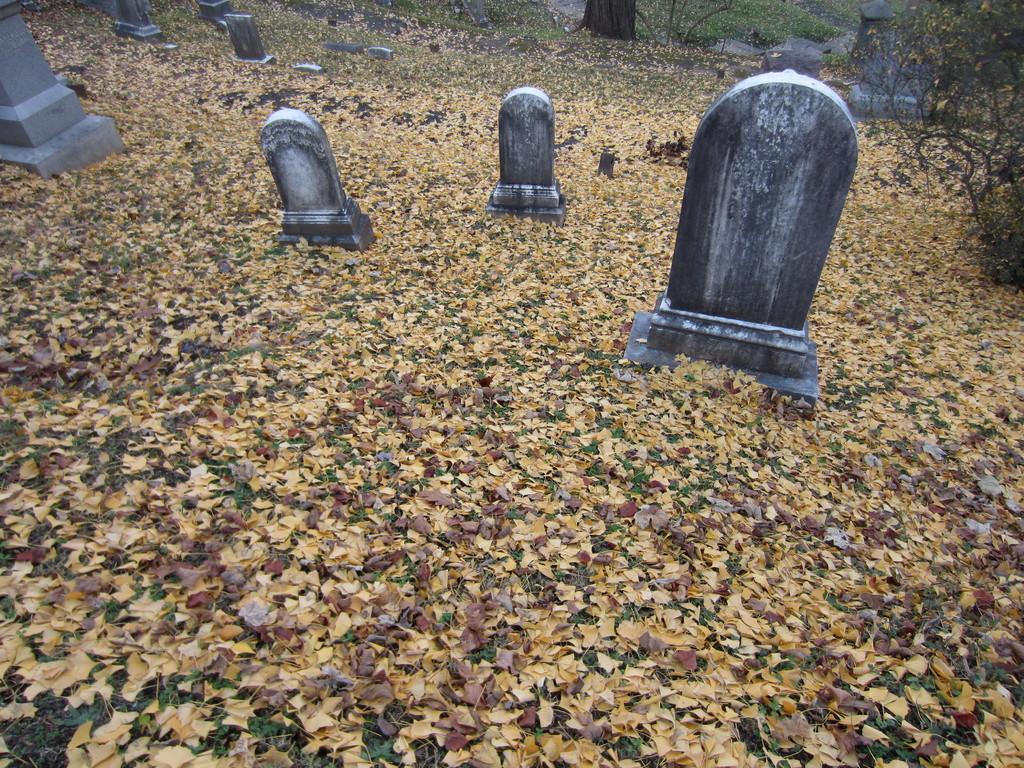Can you describe this image briefly? In the image we can see there are graves on the ground and the ground is covered with dry grass. Behind there are trees. 